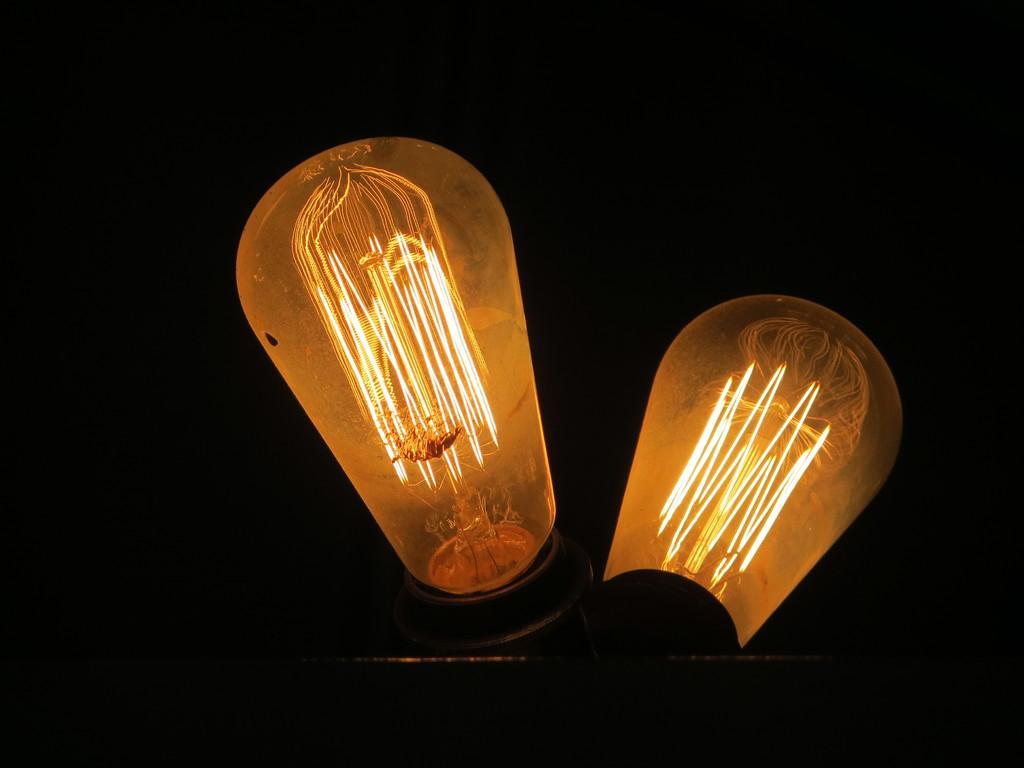Describe this image in one or two sentences. In the middle of the image, there are two lights. And the background is dark in color. 